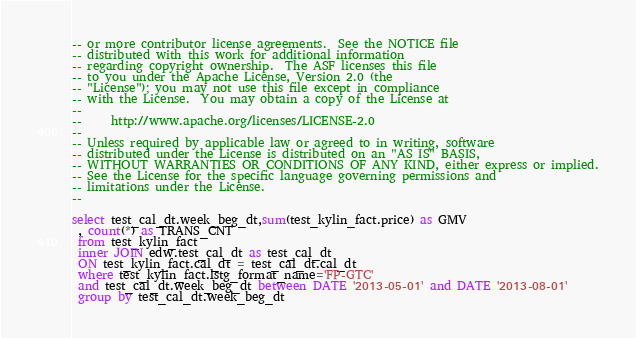Convert code to text. <code><loc_0><loc_0><loc_500><loc_500><_SQL_>-- or more contributor license agreements.  See the NOTICE file
-- distributed with this work for additional information
-- regarding copyright ownership.  The ASF licenses this file
-- to you under the Apache License, Version 2.0 (the
-- "License"); you may not use this file except in compliance
-- with the License.  You may obtain a copy of the License at
--
--     http://www.apache.org/licenses/LICENSE-2.0
--
-- Unless required by applicable law or agreed to in writing, software
-- distributed under the License is distributed on an "AS IS" BASIS,
-- WITHOUT WARRANTIES OR CONDITIONS OF ANY KIND, either express or implied.
-- See the License for the specific language governing permissions and
-- limitations under the License.
--

select test_cal_dt.week_beg_dt,sum(test_kylin_fact.price) as GMV 
 , count(*) as TRANS_CNT 
 from test_kylin_fact 
 inner JOIN edw.test_cal_dt as test_cal_dt  
 ON test_kylin_fact.cal_dt = test_cal_dt.cal_dt 
 where test_kylin_fact.lstg_format_name='FP-GTC' 
 and test_cal_dt.week_beg_dt between DATE '2013-05-01' and DATE '2013-08-01' 
 group by test_cal_dt.week_beg_dt 
</code> 